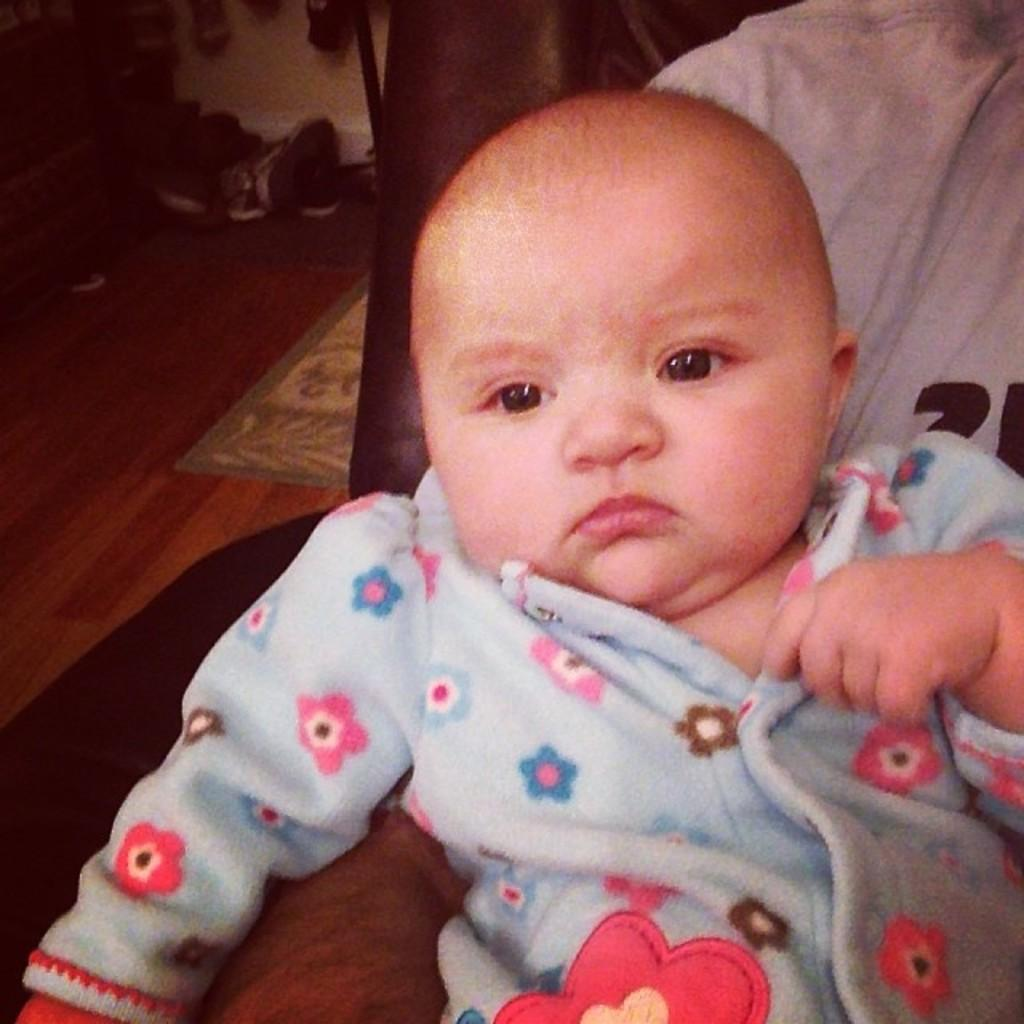What is the main subject of the image? The main subject of the image is a small kid. What is the surface beneath the kid? There is a floor in the image. Is there any object on the floor? Yes, there is a floor mat on the floor. What type of drink is the kid holding in the image? There is no drink visible in the image; the main subject is a small kid. 